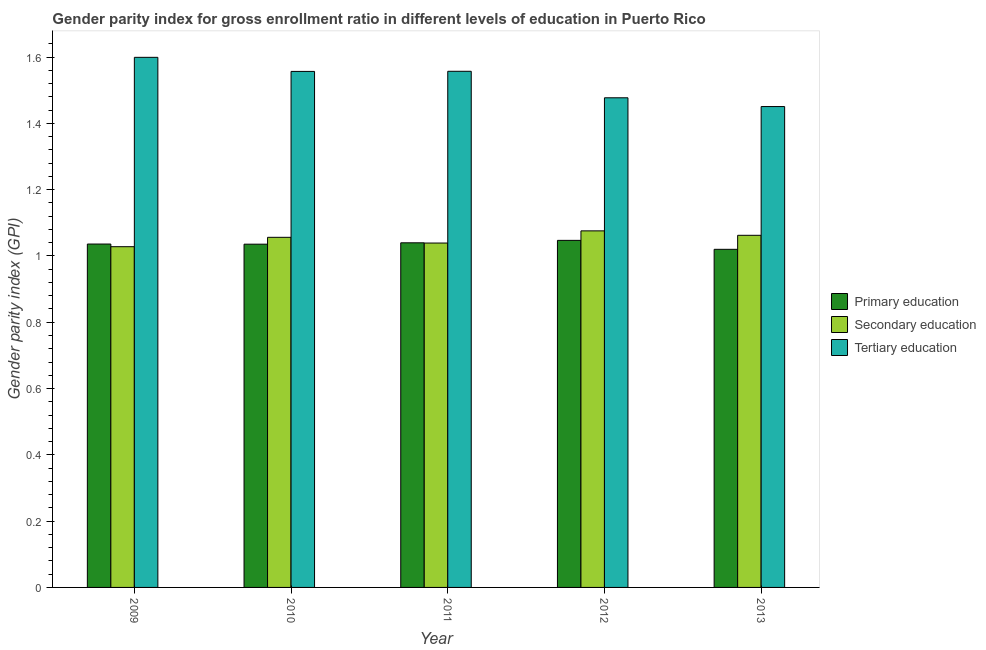How many groups of bars are there?
Give a very brief answer. 5. Are the number of bars on each tick of the X-axis equal?
Give a very brief answer. Yes. How many bars are there on the 2nd tick from the left?
Your response must be concise. 3. What is the label of the 3rd group of bars from the left?
Make the answer very short. 2011. In how many cases, is the number of bars for a given year not equal to the number of legend labels?
Provide a short and direct response. 0. What is the gender parity index in secondary education in 2012?
Offer a terse response. 1.08. Across all years, what is the maximum gender parity index in secondary education?
Provide a short and direct response. 1.08. Across all years, what is the minimum gender parity index in secondary education?
Offer a terse response. 1.03. What is the total gender parity index in tertiary education in the graph?
Offer a terse response. 7.64. What is the difference between the gender parity index in primary education in 2009 and that in 2010?
Your answer should be compact. 0. What is the difference between the gender parity index in secondary education in 2009 and the gender parity index in tertiary education in 2012?
Your response must be concise. -0.05. What is the average gender parity index in secondary education per year?
Provide a short and direct response. 1.05. In the year 2010, what is the difference between the gender parity index in secondary education and gender parity index in primary education?
Your response must be concise. 0. What is the ratio of the gender parity index in secondary education in 2009 to that in 2011?
Your answer should be compact. 0.99. Is the gender parity index in secondary education in 2009 less than that in 2010?
Your answer should be compact. Yes. Is the difference between the gender parity index in secondary education in 2011 and 2013 greater than the difference between the gender parity index in primary education in 2011 and 2013?
Your answer should be compact. No. What is the difference between the highest and the second highest gender parity index in tertiary education?
Give a very brief answer. 0.04. What is the difference between the highest and the lowest gender parity index in secondary education?
Your answer should be very brief. 0.05. Is the sum of the gender parity index in tertiary education in 2009 and 2010 greater than the maximum gender parity index in primary education across all years?
Give a very brief answer. Yes. What does the 2nd bar from the left in 2012 represents?
Your answer should be very brief. Secondary education. What does the 3rd bar from the right in 2012 represents?
Offer a terse response. Primary education. Is it the case that in every year, the sum of the gender parity index in primary education and gender parity index in secondary education is greater than the gender parity index in tertiary education?
Provide a short and direct response. Yes. How many bars are there?
Keep it short and to the point. 15. What is the difference between two consecutive major ticks on the Y-axis?
Ensure brevity in your answer.  0.2. Are the values on the major ticks of Y-axis written in scientific E-notation?
Offer a terse response. No. Does the graph contain any zero values?
Keep it short and to the point. No. How many legend labels are there?
Make the answer very short. 3. What is the title of the graph?
Provide a short and direct response. Gender parity index for gross enrollment ratio in different levels of education in Puerto Rico. Does "Natural gas sources" appear as one of the legend labels in the graph?
Provide a succinct answer. No. What is the label or title of the X-axis?
Give a very brief answer. Year. What is the label or title of the Y-axis?
Give a very brief answer. Gender parity index (GPI). What is the Gender parity index (GPI) of Primary education in 2009?
Provide a succinct answer. 1.04. What is the Gender parity index (GPI) in Secondary education in 2009?
Ensure brevity in your answer.  1.03. What is the Gender parity index (GPI) of Tertiary education in 2009?
Offer a very short reply. 1.6. What is the Gender parity index (GPI) of Primary education in 2010?
Offer a very short reply. 1.04. What is the Gender parity index (GPI) of Secondary education in 2010?
Your response must be concise. 1.06. What is the Gender parity index (GPI) in Tertiary education in 2010?
Provide a succinct answer. 1.56. What is the Gender parity index (GPI) in Primary education in 2011?
Keep it short and to the point. 1.04. What is the Gender parity index (GPI) in Secondary education in 2011?
Make the answer very short. 1.04. What is the Gender parity index (GPI) of Tertiary education in 2011?
Your answer should be very brief. 1.56. What is the Gender parity index (GPI) of Primary education in 2012?
Provide a short and direct response. 1.05. What is the Gender parity index (GPI) in Secondary education in 2012?
Offer a very short reply. 1.08. What is the Gender parity index (GPI) in Tertiary education in 2012?
Your answer should be very brief. 1.48. What is the Gender parity index (GPI) of Primary education in 2013?
Your answer should be very brief. 1.02. What is the Gender parity index (GPI) of Secondary education in 2013?
Your answer should be compact. 1.06. What is the Gender parity index (GPI) of Tertiary education in 2013?
Provide a succinct answer. 1.45. Across all years, what is the maximum Gender parity index (GPI) in Primary education?
Your answer should be very brief. 1.05. Across all years, what is the maximum Gender parity index (GPI) in Secondary education?
Your answer should be very brief. 1.08. Across all years, what is the maximum Gender parity index (GPI) of Tertiary education?
Make the answer very short. 1.6. Across all years, what is the minimum Gender parity index (GPI) in Primary education?
Give a very brief answer. 1.02. Across all years, what is the minimum Gender parity index (GPI) of Secondary education?
Keep it short and to the point. 1.03. Across all years, what is the minimum Gender parity index (GPI) of Tertiary education?
Provide a short and direct response. 1.45. What is the total Gender parity index (GPI) in Primary education in the graph?
Your answer should be very brief. 5.18. What is the total Gender parity index (GPI) of Secondary education in the graph?
Your response must be concise. 5.26. What is the total Gender parity index (GPI) in Tertiary education in the graph?
Your response must be concise. 7.64. What is the difference between the Gender parity index (GPI) in Secondary education in 2009 and that in 2010?
Provide a succinct answer. -0.03. What is the difference between the Gender parity index (GPI) in Tertiary education in 2009 and that in 2010?
Your answer should be very brief. 0.04. What is the difference between the Gender parity index (GPI) of Primary education in 2009 and that in 2011?
Offer a terse response. -0. What is the difference between the Gender parity index (GPI) in Secondary education in 2009 and that in 2011?
Your answer should be compact. -0.01. What is the difference between the Gender parity index (GPI) of Tertiary education in 2009 and that in 2011?
Your response must be concise. 0.04. What is the difference between the Gender parity index (GPI) in Primary education in 2009 and that in 2012?
Give a very brief answer. -0.01. What is the difference between the Gender parity index (GPI) in Secondary education in 2009 and that in 2012?
Keep it short and to the point. -0.05. What is the difference between the Gender parity index (GPI) of Tertiary education in 2009 and that in 2012?
Your answer should be very brief. 0.12. What is the difference between the Gender parity index (GPI) of Primary education in 2009 and that in 2013?
Provide a succinct answer. 0.02. What is the difference between the Gender parity index (GPI) in Secondary education in 2009 and that in 2013?
Provide a succinct answer. -0.03. What is the difference between the Gender parity index (GPI) of Tertiary education in 2009 and that in 2013?
Offer a very short reply. 0.15. What is the difference between the Gender parity index (GPI) of Primary education in 2010 and that in 2011?
Provide a short and direct response. -0. What is the difference between the Gender parity index (GPI) in Secondary education in 2010 and that in 2011?
Keep it short and to the point. 0.02. What is the difference between the Gender parity index (GPI) in Tertiary education in 2010 and that in 2011?
Make the answer very short. -0. What is the difference between the Gender parity index (GPI) in Primary education in 2010 and that in 2012?
Your answer should be compact. -0.01. What is the difference between the Gender parity index (GPI) of Secondary education in 2010 and that in 2012?
Your answer should be very brief. -0.02. What is the difference between the Gender parity index (GPI) in Tertiary education in 2010 and that in 2012?
Give a very brief answer. 0.08. What is the difference between the Gender parity index (GPI) in Primary education in 2010 and that in 2013?
Provide a short and direct response. 0.02. What is the difference between the Gender parity index (GPI) in Secondary education in 2010 and that in 2013?
Ensure brevity in your answer.  -0.01. What is the difference between the Gender parity index (GPI) in Tertiary education in 2010 and that in 2013?
Make the answer very short. 0.11. What is the difference between the Gender parity index (GPI) of Primary education in 2011 and that in 2012?
Provide a short and direct response. -0.01. What is the difference between the Gender parity index (GPI) of Secondary education in 2011 and that in 2012?
Your answer should be compact. -0.04. What is the difference between the Gender parity index (GPI) in Tertiary education in 2011 and that in 2012?
Give a very brief answer. 0.08. What is the difference between the Gender parity index (GPI) of Primary education in 2011 and that in 2013?
Offer a very short reply. 0.02. What is the difference between the Gender parity index (GPI) of Secondary education in 2011 and that in 2013?
Keep it short and to the point. -0.02. What is the difference between the Gender parity index (GPI) of Tertiary education in 2011 and that in 2013?
Keep it short and to the point. 0.11. What is the difference between the Gender parity index (GPI) in Primary education in 2012 and that in 2013?
Offer a terse response. 0.03. What is the difference between the Gender parity index (GPI) of Secondary education in 2012 and that in 2013?
Offer a very short reply. 0.01. What is the difference between the Gender parity index (GPI) in Tertiary education in 2012 and that in 2013?
Give a very brief answer. 0.03. What is the difference between the Gender parity index (GPI) of Primary education in 2009 and the Gender parity index (GPI) of Secondary education in 2010?
Offer a very short reply. -0.02. What is the difference between the Gender parity index (GPI) in Primary education in 2009 and the Gender parity index (GPI) in Tertiary education in 2010?
Give a very brief answer. -0.52. What is the difference between the Gender parity index (GPI) of Secondary education in 2009 and the Gender parity index (GPI) of Tertiary education in 2010?
Give a very brief answer. -0.53. What is the difference between the Gender parity index (GPI) in Primary education in 2009 and the Gender parity index (GPI) in Secondary education in 2011?
Your answer should be compact. -0. What is the difference between the Gender parity index (GPI) of Primary education in 2009 and the Gender parity index (GPI) of Tertiary education in 2011?
Offer a very short reply. -0.52. What is the difference between the Gender parity index (GPI) of Secondary education in 2009 and the Gender parity index (GPI) of Tertiary education in 2011?
Your answer should be very brief. -0.53. What is the difference between the Gender parity index (GPI) of Primary education in 2009 and the Gender parity index (GPI) of Secondary education in 2012?
Offer a very short reply. -0.04. What is the difference between the Gender parity index (GPI) of Primary education in 2009 and the Gender parity index (GPI) of Tertiary education in 2012?
Make the answer very short. -0.44. What is the difference between the Gender parity index (GPI) in Secondary education in 2009 and the Gender parity index (GPI) in Tertiary education in 2012?
Your response must be concise. -0.45. What is the difference between the Gender parity index (GPI) in Primary education in 2009 and the Gender parity index (GPI) in Secondary education in 2013?
Offer a terse response. -0.03. What is the difference between the Gender parity index (GPI) of Primary education in 2009 and the Gender parity index (GPI) of Tertiary education in 2013?
Offer a very short reply. -0.41. What is the difference between the Gender parity index (GPI) in Secondary education in 2009 and the Gender parity index (GPI) in Tertiary education in 2013?
Provide a short and direct response. -0.42. What is the difference between the Gender parity index (GPI) of Primary education in 2010 and the Gender parity index (GPI) of Secondary education in 2011?
Give a very brief answer. -0. What is the difference between the Gender parity index (GPI) in Primary education in 2010 and the Gender parity index (GPI) in Tertiary education in 2011?
Keep it short and to the point. -0.52. What is the difference between the Gender parity index (GPI) of Secondary education in 2010 and the Gender parity index (GPI) of Tertiary education in 2011?
Your response must be concise. -0.5. What is the difference between the Gender parity index (GPI) of Primary education in 2010 and the Gender parity index (GPI) of Secondary education in 2012?
Make the answer very short. -0.04. What is the difference between the Gender parity index (GPI) of Primary education in 2010 and the Gender parity index (GPI) of Tertiary education in 2012?
Keep it short and to the point. -0.44. What is the difference between the Gender parity index (GPI) in Secondary education in 2010 and the Gender parity index (GPI) in Tertiary education in 2012?
Offer a very short reply. -0.42. What is the difference between the Gender parity index (GPI) of Primary education in 2010 and the Gender parity index (GPI) of Secondary education in 2013?
Make the answer very short. -0.03. What is the difference between the Gender parity index (GPI) in Primary education in 2010 and the Gender parity index (GPI) in Tertiary education in 2013?
Your answer should be very brief. -0.42. What is the difference between the Gender parity index (GPI) in Secondary education in 2010 and the Gender parity index (GPI) in Tertiary education in 2013?
Give a very brief answer. -0.39. What is the difference between the Gender parity index (GPI) in Primary education in 2011 and the Gender parity index (GPI) in Secondary education in 2012?
Make the answer very short. -0.04. What is the difference between the Gender parity index (GPI) of Primary education in 2011 and the Gender parity index (GPI) of Tertiary education in 2012?
Provide a succinct answer. -0.44. What is the difference between the Gender parity index (GPI) of Secondary education in 2011 and the Gender parity index (GPI) of Tertiary education in 2012?
Your response must be concise. -0.44. What is the difference between the Gender parity index (GPI) in Primary education in 2011 and the Gender parity index (GPI) in Secondary education in 2013?
Ensure brevity in your answer.  -0.02. What is the difference between the Gender parity index (GPI) of Primary education in 2011 and the Gender parity index (GPI) of Tertiary education in 2013?
Provide a short and direct response. -0.41. What is the difference between the Gender parity index (GPI) in Secondary education in 2011 and the Gender parity index (GPI) in Tertiary education in 2013?
Your answer should be very brief. -0.41. What is the difference between the Gender parity index (GPI) of Primary education in 2012 and the Gender parity index (GPI) of Secondary education in 2013?
Your answer should be compact. -0.02. What is the difference between the Gender parity index (GPI) of Primary education in 2012 and the Gender parity index (GPI) of Tertiary education in 2013?
Give a very brief answer. -0.4. What is the difference between the Gender parity index (GPI) in Secondary education in 2012 and the Gender parity index (GPI) in Tertiary education in 2013?
Your answer should be very brief. -0.38. What is the average Gender parity index (GPI) of Primary education per year?
Make the answer very short. 1.04. What is the average Gender parity index (GPI) in Secondary education per year?
Your answer should be compact. 1.05. What is the average Gender parity index (GPI) in Tertiary education per year?
Ensure brevity in your answer.  1.53. In the year 2009, what is the difference between the Gender parity index (GPI) in Primary education and Gender parity index (GPI) in Secondary education?
Keep it short and to the point. 0.01. In the year 2009, what is the difference between the Gender parity index (GPI) of Primary education and Gender parity index (GPI) of Tertiary education?
Offer a very short reply. -0.56. In the year 2009, what is the difference between the Gender parity index (GPI) in Secondary education and Gender parity index (GPI) in Tertiary education?
Your answer should be compact. -0.57. In the year 2010, what is the difference between the Gender parity index (GPI) in Primary education and Gender parity index (GPI) in Secondary education?
Ensure brevity in your answer.  -0.02. In the year 2010, what is the difference between the Gender parity index (GPI) of Primary education and Gender parity index (GPI) of Tertiary education?
Your response must be concise. -0.52. In the year 2010, what is the difference between the Gender parity index (GPI) in Secondary education and Gender parity index (GPI) in Tertiary education?
Your answer should be very brief. -0.5. In the year 2011, what is the difference between the Gender parity index (GPI) in Primary education and Gender parity index (GPI) in Secondary education?
Offer a terse response. 0. In the year 2011, what is the difference between the Gender parity index (GPI) in Primary education and Gender parity index (GPI) in Tertiary education?
Ensure brevity in your answer.  -0.52. In the year 2011, what is the difference between the Gender parity index (GPI) of Secondary education and Gender parity index (GPI) of Tertiary education?
Provide a short and direct response. -0.52. In the year 2012, what is the difference between the Gender parity index (GPI) of Primary education and Gender parity index (GPI) of Secondary education?
Your answer should be compact. -0.03. In the year 2012, what is the difference between the Gender parity index (GPI) in Primary education and Gender parity index (GPI) in Tertiary education?
Offer a very short reply. -0.43. In the year 2012, what is the difference between the Gender parity index (GPI) in Secondary education and Gender parity index (GPI) in Tertiary education?
Give a very brief answer. -0.4. In the year 2013, what is the difference between the Gender parity index (GPI) of Primary education and Gender parity index (GPI) of Secondary education?
Your answer should be very brief. -0.04. In the year 2013, what is the difference between the Gender parity index (GPI) in Primary education and Gender parity index (GPI) in Tertiary education?
Your response must be concise. -0.43. In the year 2013, what is the difference between the Gender parity index (GPI) of Secondary education and Gender parity index (GPI) of Tertiary education?
Your response must be concise. -0.39. What is the ratio of the Gender parity index (GPI) of Primary education in 2009 to that in 2010?
Your response must be concise. 1. What is the ratio of the Gender parity index (GPI) of Secondary education in 2009 to that in 2010?
Offer a very short reply. 0.97. What is the ratio of the Gender parity index (GPI) in Tertiary education in 2009 to that in 2010?
Give a very brief answer. 1.03. What is the ratio of the Gender parity index (GPI) in Primary education in 2009 to that in 2011?
Ensure brevity in your answer.  1. What is the ratio of the Gender parity index (GPI) of Secondary education in 2009 to that in 2011?
Give a very brief answer. 0.99. What is the ratio of the Gender parity index (GPI) of Secondary education in 2009 to that in 2012?
Your answer should be compact. 0.96. What is the ratio of the Gender parity index (GPI) of Tertiary education in 2009 to that in 2012?
Offer a terse response. 1.08. What is the ratio of the Gender parity index (GPI) of Primary education in 2009 to that in 2013?
Your answer should be compact. 1.02. What is the ratio of the Gender parity index (GPI) of Secondary education in 2009 to that in 2013?
Your answer should be very brief. 0.97. What is the ratio of the Gender parity index (GPI) in Tertiary education in 2009 to that in 2013?
Provide a succinct answer. 1.1. What is the ratio of the Gender parity index (GPI) in Primary education in 2010 to that in 2011?
Keep it short and to the point. 1. What is the ratio of the Gender parity index (GPI) of Secondary education in 2010 to that in 2011?
Provide a short and direct response. 1.02. What is the ratio of the Gender parity index (GPI) of Primary education in 2010 to that in 2012?
Ensure brevity in your answer.  0.99. What is the ratio of the Gender parity index (GPI) of Secondary education in 2010 to that in 2012?
Your answer should be very brief. 0.98. What is the ratio of the Gender parity index (GPI) in Tertiary education in 2010 to that in 2012?
Ensure brevity in your answer.  1.05. What is the ratio of the Gender parity index (GPI) in Primary education in 2010 to that in 2013?
Your answer should be very brief. 1.02. What is the ratio of the Gender parity index (GPI) in Tertiary education in 2010 to that in 2013?
Your response must be concise. 1.07. What is the ratio of the Gender parity index (GPI) in Secondary education in 2011 to that in 2012?
Ensure brevity in your answer.  0.97. What is the ratio of the Gender parity index (GPI) in Tertiary education in 2011 to that in 2012?
Keep it short and to the point. 1.05. What is the ratio of the Gender parity index (GPI) of Primary education in 2011 to that in 2013?
Your answer should be compact. 1.02. What is the ratio of the Gender parity index (GPI) of Tertiary education in 2011 to that in 2013?
Give a very brief answer. 1.07. What is the ratio of the Gender parity index (GPI) of Primary education in 2012 to that in 2013?
Offer a very short reply. 1.03. What is the ratio of the Gender parity index (GPI) of Secondary education in 2012 to that in 2013?
Make the answer very short. 1.01. What is the ratio of the Gender parity index (GPI) of Tertiary education in 2012 to that in 2013?
Make the answer very short. 1.02. What is the difference between the highest and the second highest Gender parity index (GPI) in Primary education?
Your response must be concise. 0.01. What is the difference between the highest and the second highest Gender parity index (GPI) of Secondary education?
Your answer should be compact. 0.01. What is the difference between the highest and the second highest Gender parity index (GPI) of Tertiary education?
Your answer should be compact. 0.04. What is the difference between the highest and the lowest Gender parity index (GPI) in Primary education?
Ensure brevity in your answer.  0.03. What is the difference between the highest and the lowest Gender parity index (GPI) of Secondary education?
Offer a very short reply. 0.05. What is the difference between the highest and the lowest Gender parity index (GPI) in Tertiary education?
Make the answer very short. 0.15. 